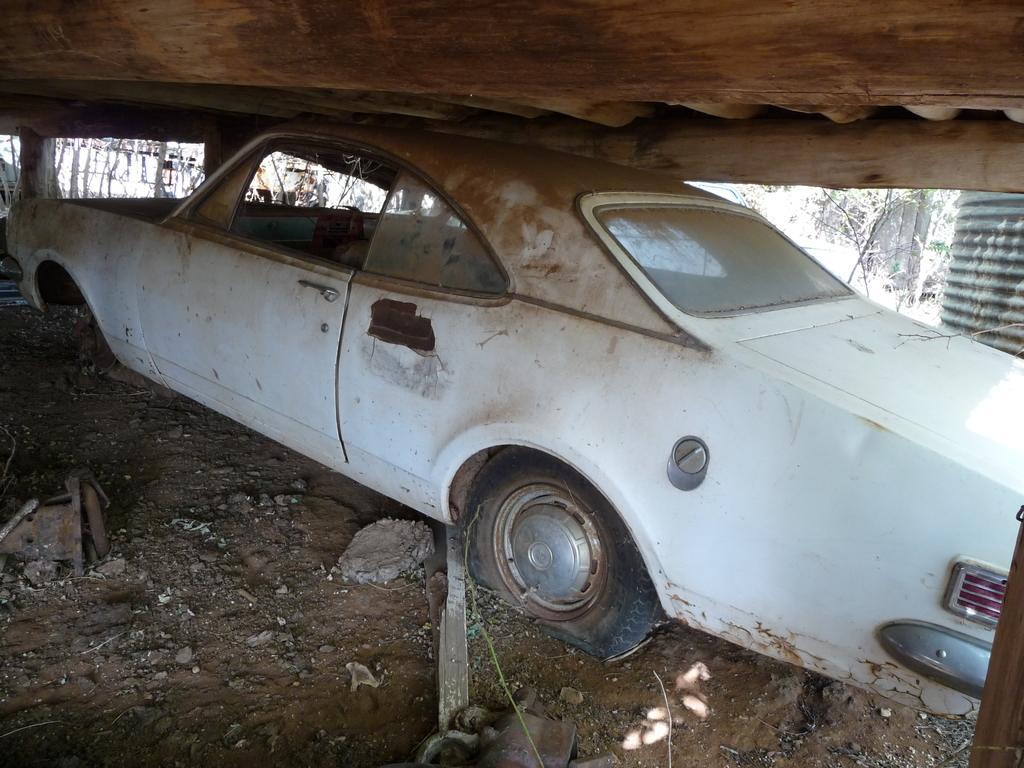Can you describe this image briefly? This image consists of car. It is in white color. 